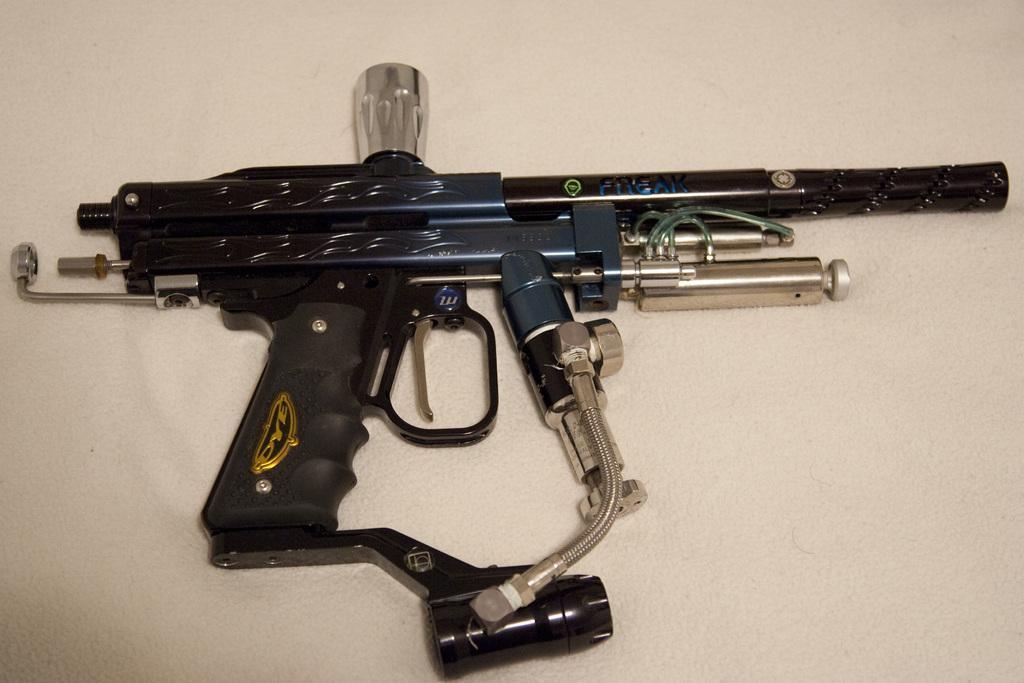Could you give a brief overview of what you see in this image? This is the picture of a gun which is in blue, black and silver color. 